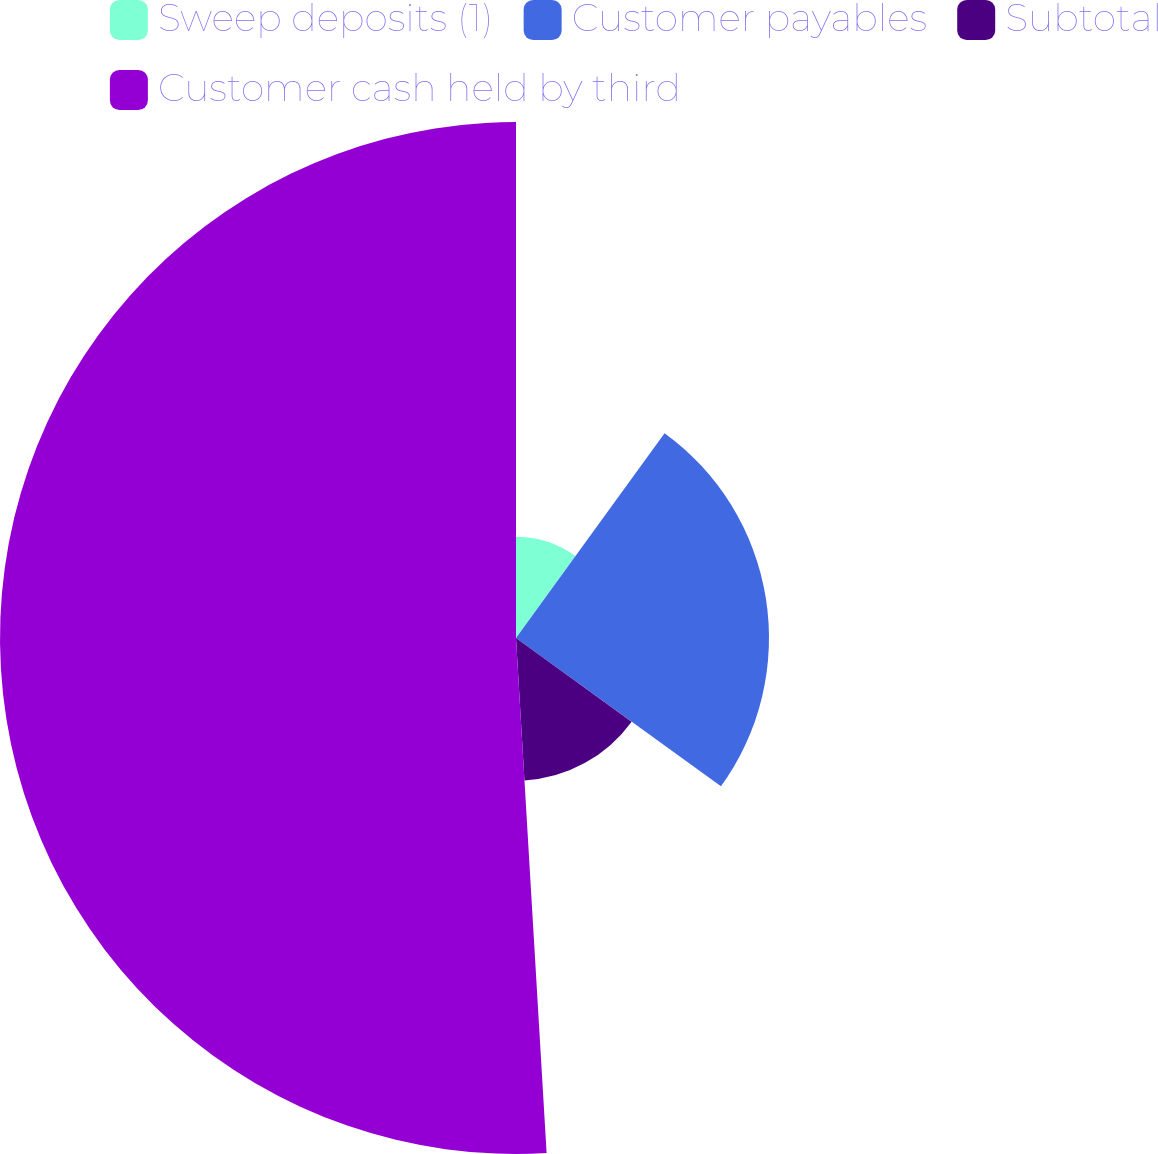Convert chart. <chart><loc_0><loc_0><loc_500><loc_500><pie_chart><fcel>Sweep deposits (1)<fcel>Customer payables<fcel>Subtotal<fcel>Customer cash held by third<nl><fcel>9.99%<fcel>24.98%<fcel>14.09%<fcel>50.95%<nl></chart> 